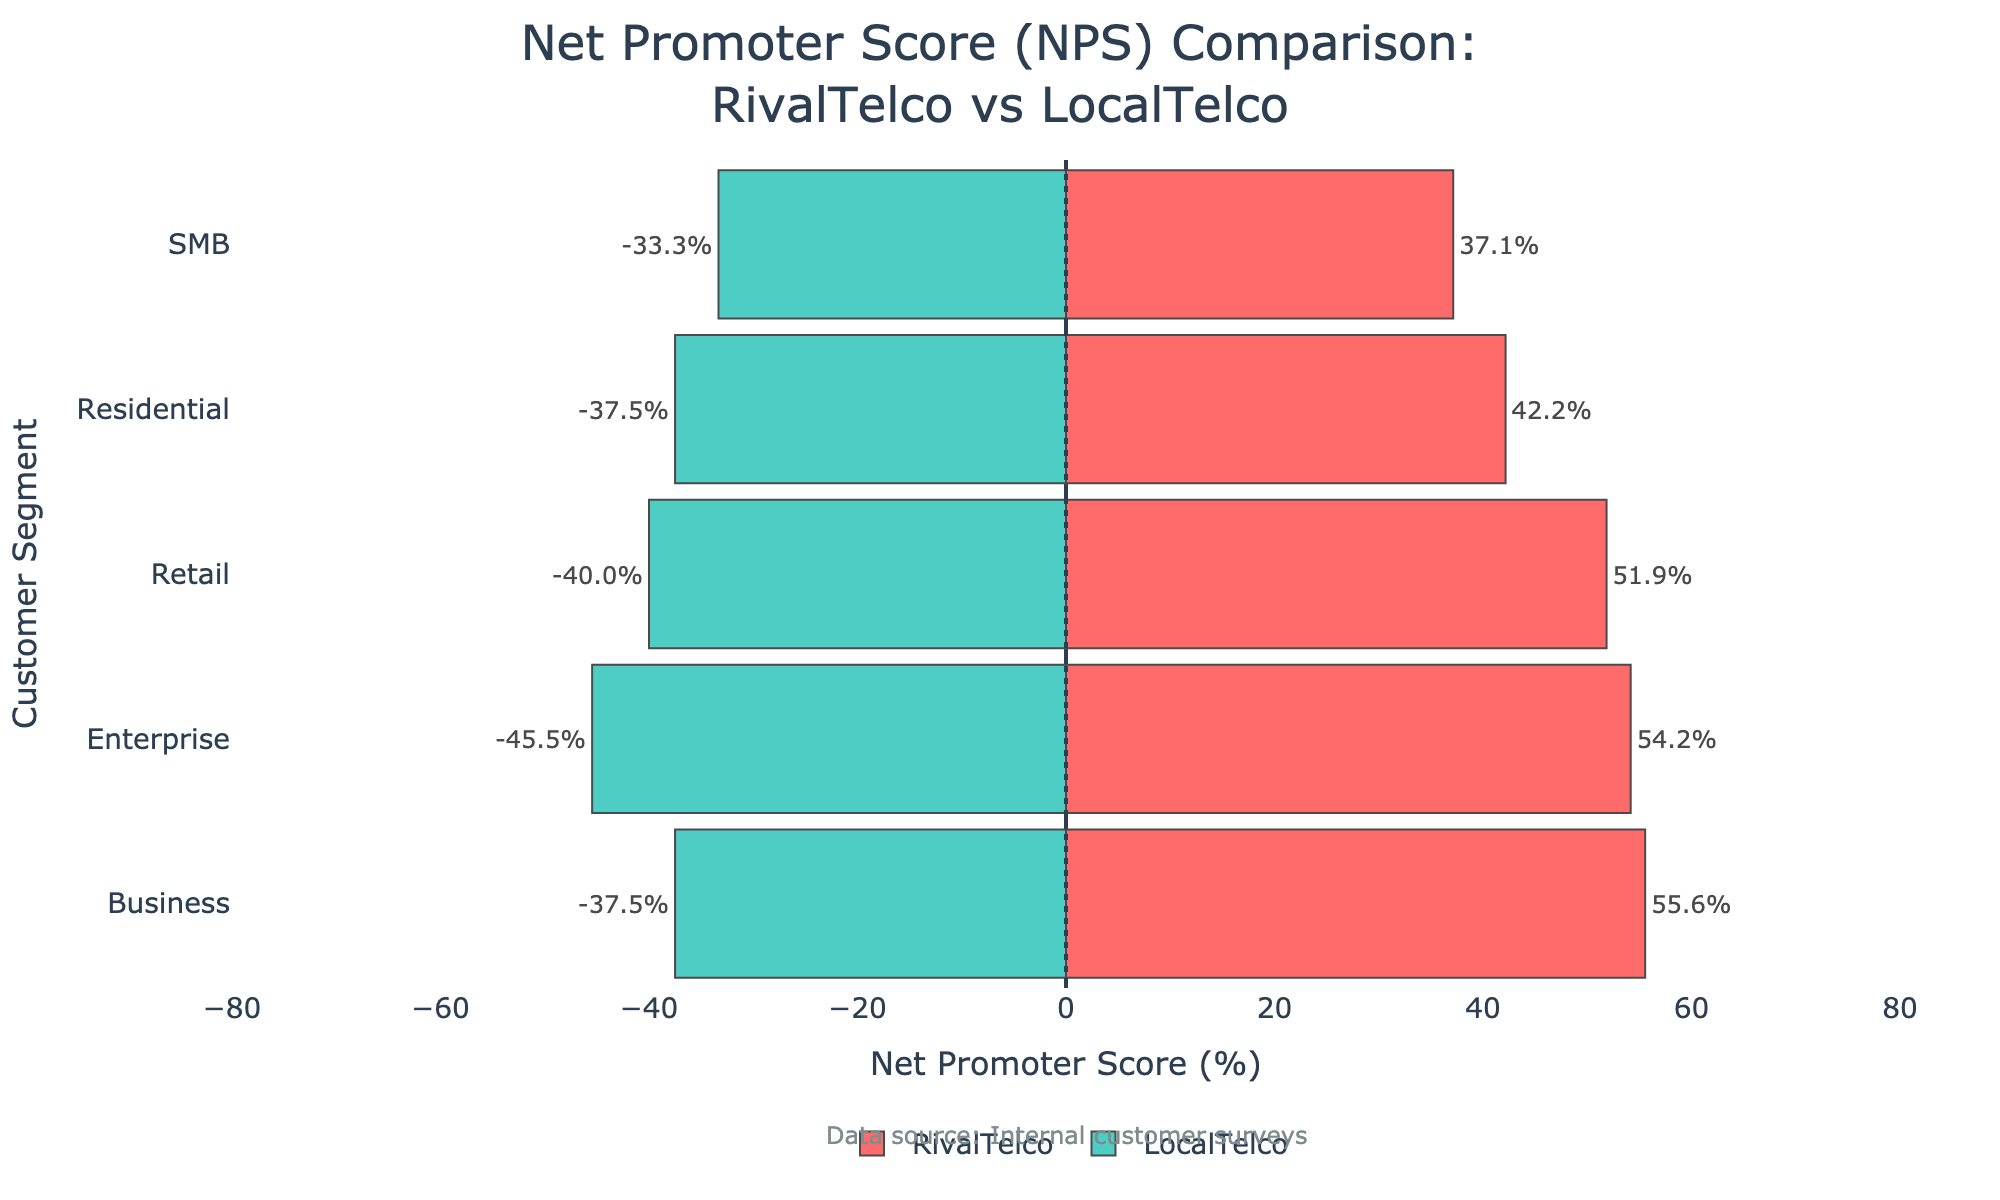What's the NPS value for the Business segment of RivalTelco? The Business segment of RivalTelco shows a red bar on the positive side of the chart. The NPS value displayed beside this bar is 62.5%.
Answer: 62.5% Which customer segment has the highest NPS for LocalTelco? By checking the length and position of the green bars on the LocalTelco side of the plot, the Retail segment stands out as having the highest NPS value, as the bar is longer than the others. The exact value can be seen to the left of the bar, which shows 38.5%.
Answer: Retail Compare the NPS values of the Enterprise segment for both RivalTelco and LocalTelco. The NPS value for the Enterprise segment of RivalTelco is shown as 62.5%, and for LocalTelco, it is shown as 50.0%, both represented by their respective bars.
Answer: RivalTelco: 62.5%, LocalTelco: 50.0% Which company has a higher NPS in the Residential segment? The NPS values for the Residential segment are displayed on both sides of the zero line in the figure. RivalTelco has an NPS of 43.8%, while LocalTelco has an NPS of 37.5%. Since 43.8% > 37.5%, RivalTelco has a higher NPS in the Residential segment.
Answer: RivalTelco Calculate the average NPS value for all segments of LocalTelco. First, extract the NPS values for LocalTelco: Business (60.0%), Retail (38.5%), SMB (33.3%), Enterprise (50.0%), and Residential (37.5%). Then sum these values: 60.0 + 38.5 + 33.3 + 50.0 + 37.5 = 219.3. Finally, divide by the number of segments (5): 219.3 / 5 = 43.86%.
Answer: 43.86% For which segment is the difference in NPS between RivalTelco and LocalTelco the smallest? Calculate the NPS differences for each segment: Business (62.5 - 60 = 2.5), Retail (48.1 - 38.5 = 9.6), SMB (45.0 - 33.3 = 11.7), Enterprise (62.5 - 50.0 = 12.5), and Residential (43.8 - 37.5 = 6.3). The smallest difference is 2.5 in the Business segment.
Answer: Business Which customer segment has the lowest NPS for RivalTelco? By looking at the red bars for RivalTelco and comparing their lengths and labels, the SMB segment has the shortest bar with a value of 45.0%.
Answer: SMB What is the NPS value range for RivalTelco across all segments? The highest NPS value for RivalTelco is in the Business and Enterprise segments (both 62.5%), and the lowest is in the SMB segment (45.0%). Therefore, the range is 62.5 - 45.0 = 17.5%.
Answer: 17.5% What is the combined average NPS value of all segments for both companies? Extract NPS values for RivalTelco (62.5, 48.1, 45.0, 62.5, 43.8) and LocalTelco (60.0, 38.5, 33.3, 50.0, 37.5). Calculate their sums: 62.5 + 48.1 + 45.0 + 62.5 + 43.8 = 261.9 and 60.0 + 38.5 + 33.3 + 50.0 + 37.5 = 219.3. Combine both sums: 261.9 + 219.3 = 481.2. There are 10 segments combined. Hence, the average is 481.2 / 10 = 48.12%.
Answer: 48.12% 